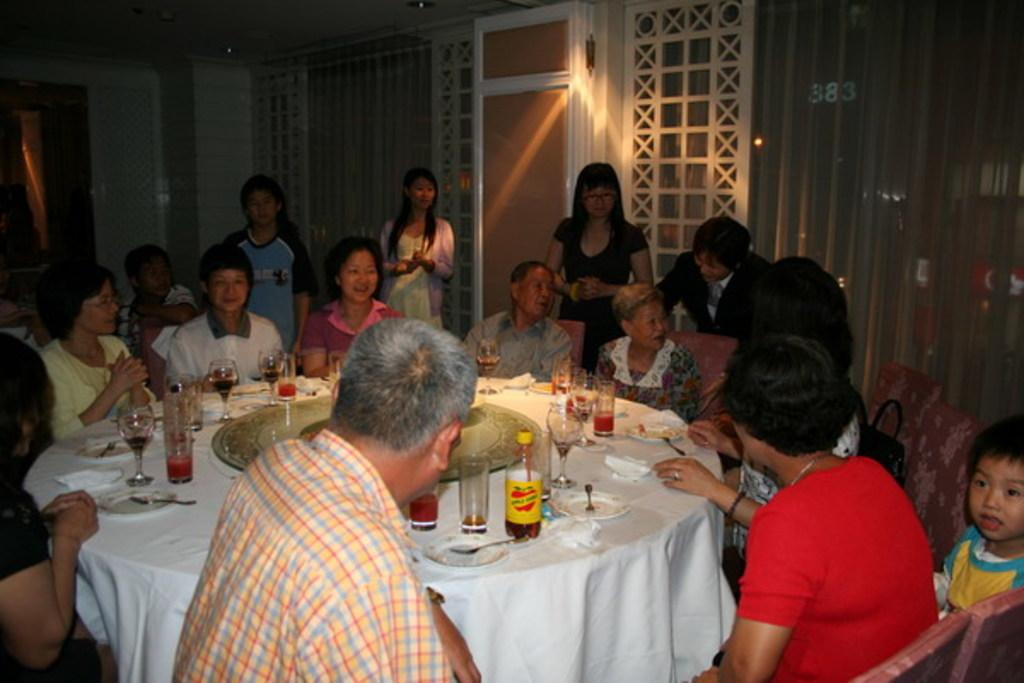What are the people in the image doing? People are seated around the table in the image. What are the people sitting on? The people are seated on chairs. What objects can be seen on the table? There are plates, knives, and glasses on the table. How many people are standing at the back? Four people are standing at the back. What is visible behind the standing people? There is a door visible behind the standing people. How long does it take for the pancake to cook in the image? There is no pancake present in the image, so it is not possible to determine how long it would take to cook. 